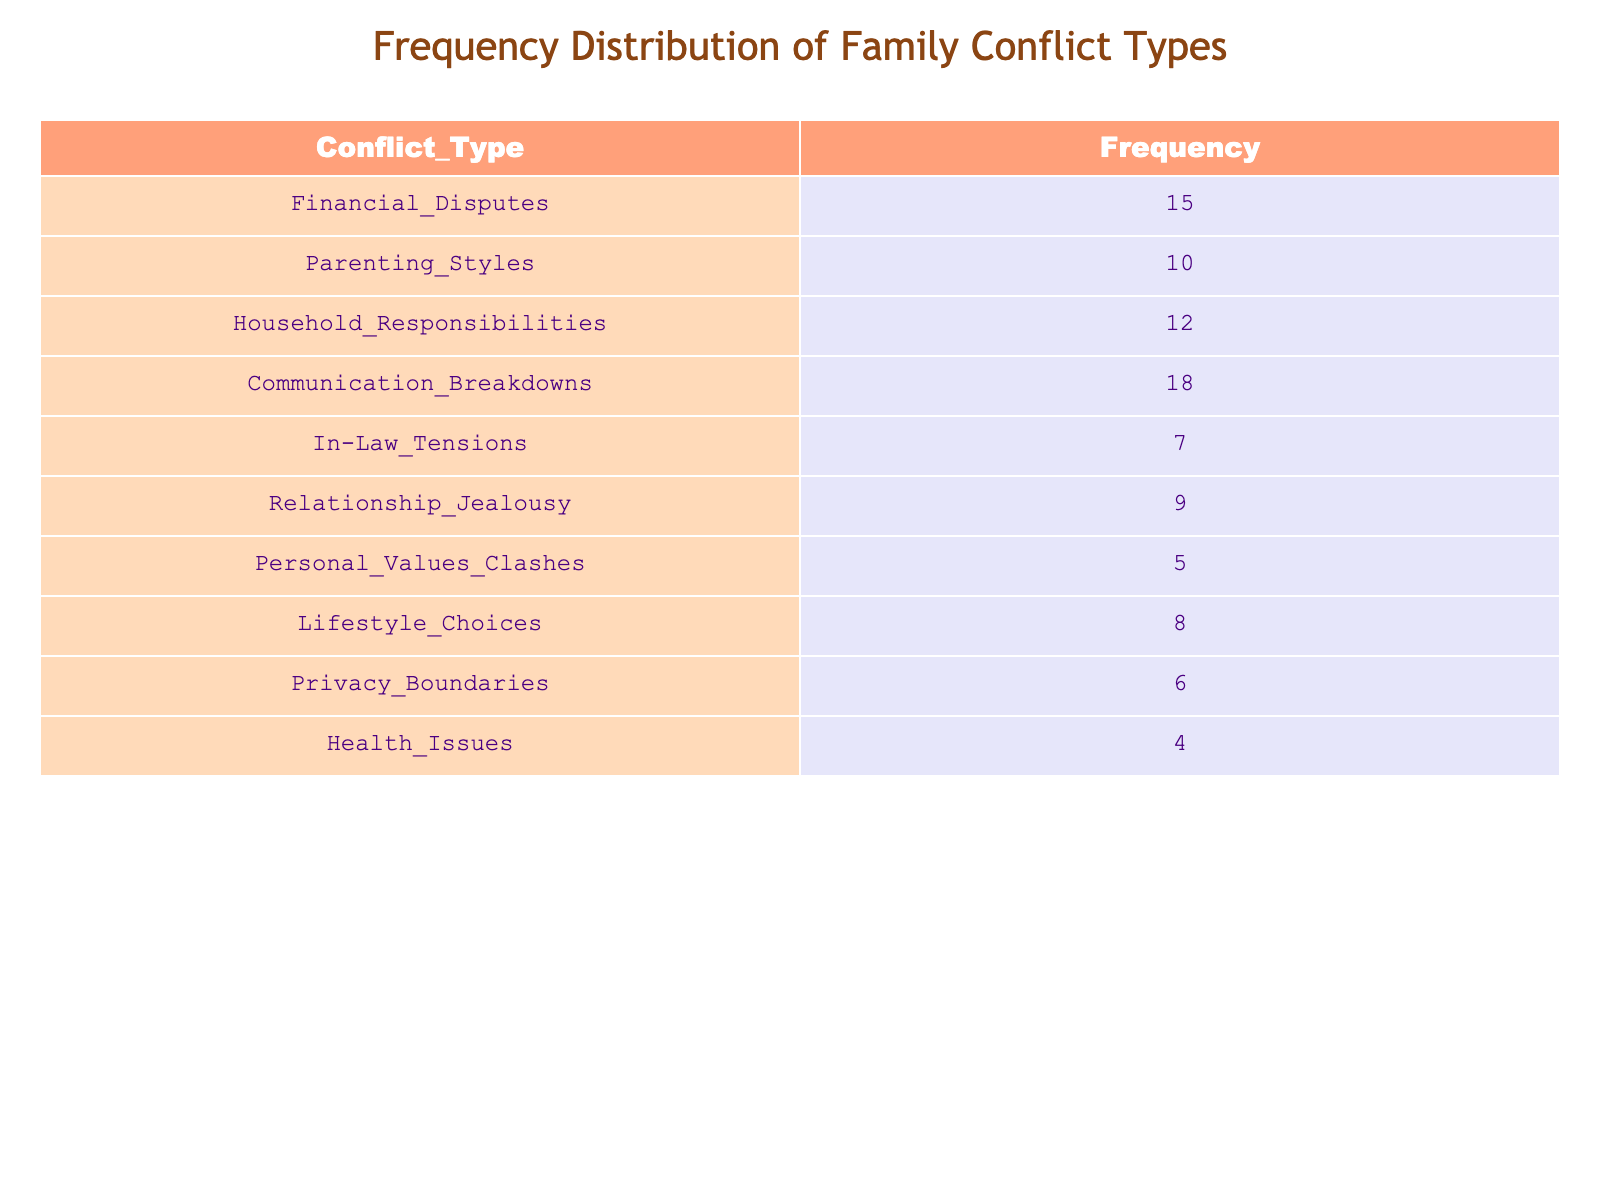What is the most frequent type of conflict in family interactions? The table shows that "Communication Breakdowns" has the highest frequency at 18.
Answer: 18 How many conflict types have a frequency of 10 or more? The conflict types with frequencies of 10 or more are Financial Disputes (15), Parenting Styles (10), Household Responsibilities (12), and Communication Breakdowns (18), totaling 4 types.
Answer: 4 Is "Health Issues" one of the top three conflict types? The frequency of "Health Issues" is 4, which is lower than the frequencies of the top three conflict types (Communication Breakdowns, Household Responsibilities, and Financial Disputes).
Answer: No What is the difference in frequency between the most and least common conflict types? The most common conflict type is "Communication Breakdowns" with a frequency of 18, and the least common is "Health Issues" with a frequency of 4. The difference is 18 - 4 = 14.
Answer: 14 What is the average frequency of all conflict types? To calculate the average, first sum the frequencies: 15 + 10 + 12 + 18 + 7 + 9 + 5 + 8 + 6 + 4 = 94. There are 10 conflict types, so the average is 94 / 10 = 9.4.
Answer: 9.4 